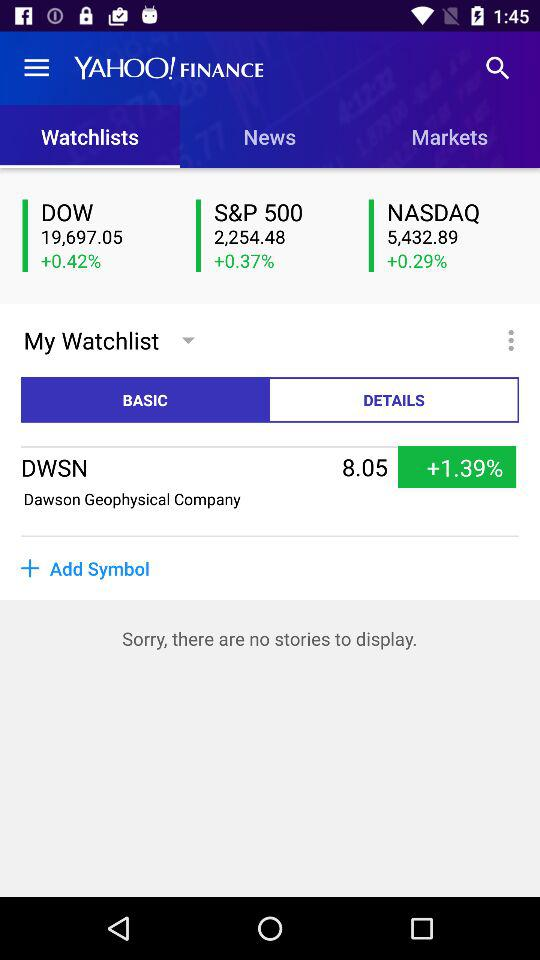What is the percentage change for Dawson Geophysical Company?
Answer the question using a single word or phrase. +1.39% 